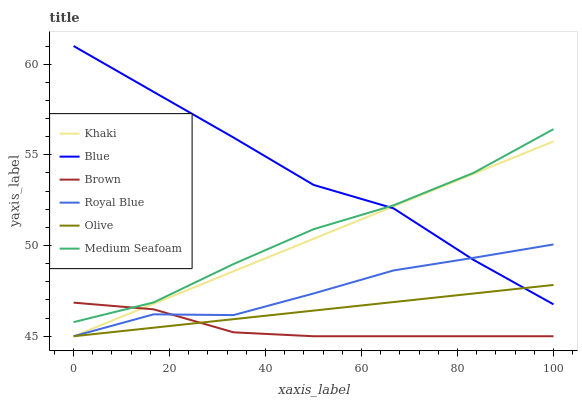Does Brown have the minimum area under the curve?
Answer yes or no. Yes. Does Blue have the maximum area under the curve?
Answer yes or no. Yes. Does Khaki have the minimum area under the curve?
Answer yes or no. No. Does Khaki have the maximum area under the curve?
Answer yes or no. No. Is Khaki the smoothest?
Answer yes or no. Yes. Is Blue the roughest?
Answer yes or no. Yes. Is Brown the smoothest?
Answer yes or no. No. Is Brown the roughest?
Answer yes or no. No. Does Brown have the lowest value?
Answer yes or no. Yes. Does Medium Seafoam have the lowest value?
Answer yes or no. No. Does Blue have the highest value?
Answer yes or no. Yes. Does Khaki have the highest value?
Answer yes or no. No. Is Brown less than Blue?
Answer yes or no. Yes. Is Medium Seafoam greater than Royal Blue?
Answer yes or no. Yes. Does Brown intersect Medium Seafoam?
Answer yes or no. Yes. Is Brown less than Medium Seafoam?
Answer yes or no. No. Is Brown greater than Medium Seafoam?
Answer yes or no. No. Does Brown intersect Blue?
Answer yes or no. No. 